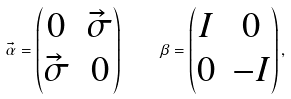Convert formula to latex. <formula><loc_0><loc_0><loc_500><loc_500>\vec { \alpha } = \begin{pmatrix} 0 & \vec { \sigma } \\ \vec { \sigma } & 0 \end{pmatrix} \quad \beta = \begin{pmatrix} I & 0 \\ 0 & { - I } \end{pmatrix} ,</formula> 